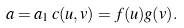<formula> <loc_0><loc_0><loc_500><loc_500>a = a _ { 1 } \, c ( u , v ) = f ( u ) g ( v ) .</formula> 